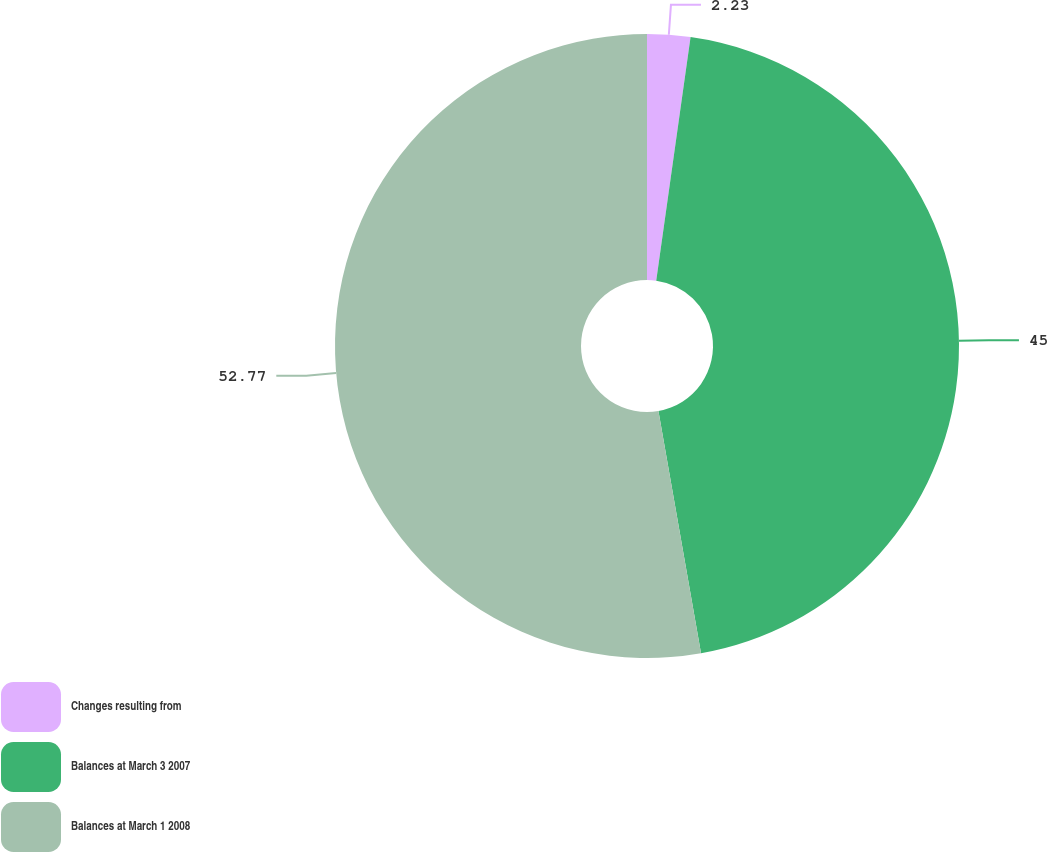Convert chart to OTSL. <chart><loc_0><loc_0><loc_500><loc_500><pie_chart><fcel>Changes resulting from<fcel>Balances at March 3 2007<fcel>Balances at March 1 2008<nl><fcel>2.23%<fcel>45.0%<fcel>52.77%<nl></chart> 